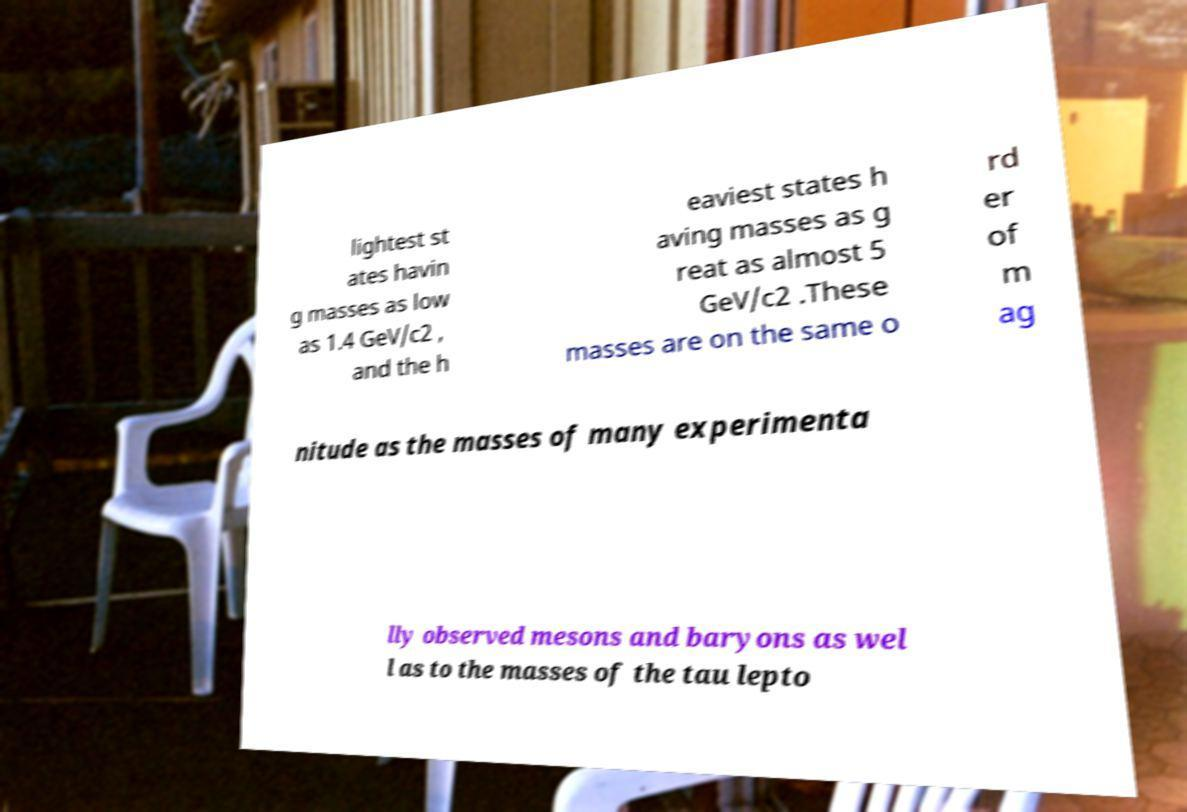Could you extract and type out the text from this image? lightest st ates havin g masses as low as 1.4 GeV/c2 , and the h eaviest states h aving masses as g reat as almost 5 GeV/c2 .These masses are on the same o rd er of m ag nitude as the masses of many experimenta lly observed mesons and baryons as wel l as to the masses of the tau lepto 